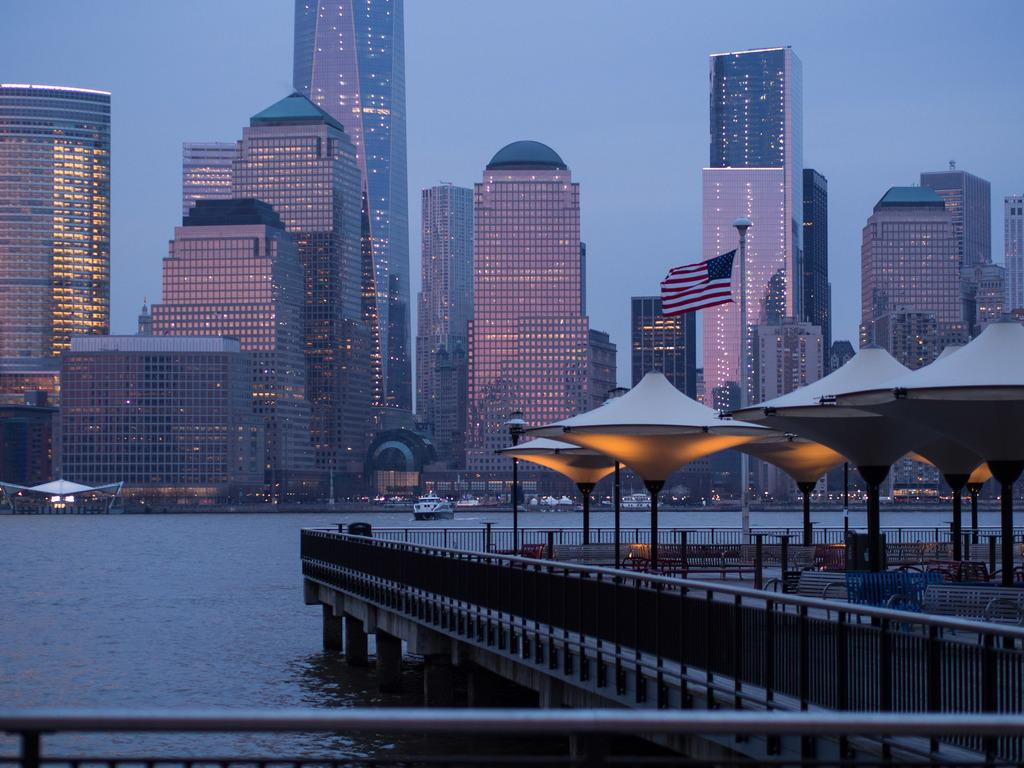What is the main subject of the image? The main subject of the image is the many buildings. What can be seen in front of the buildings? There is a lake in front of the buildings. What type of throat condition can be seen in the image? There is no throat condition present in the image; it features buildings and a lake. What type of loss is depicted in the image? There is no loss depicted in the image; it features buildings and a lake. 